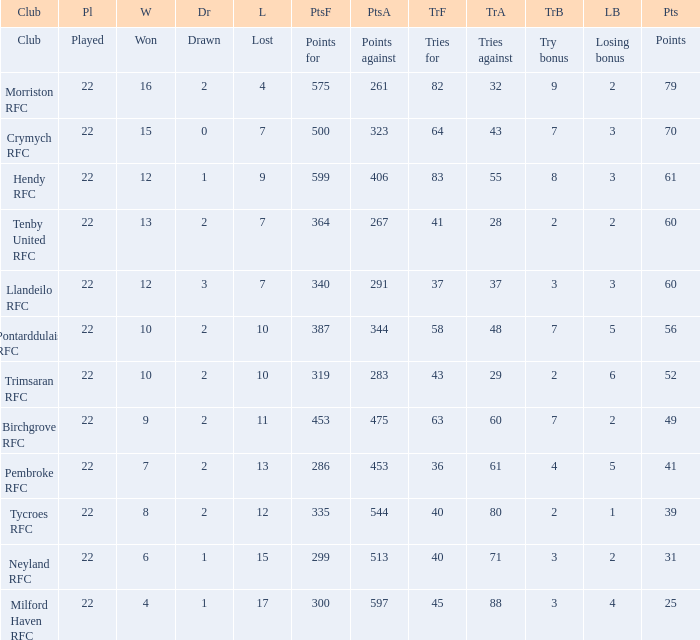What's the won with try bonus being 8 12.0. 